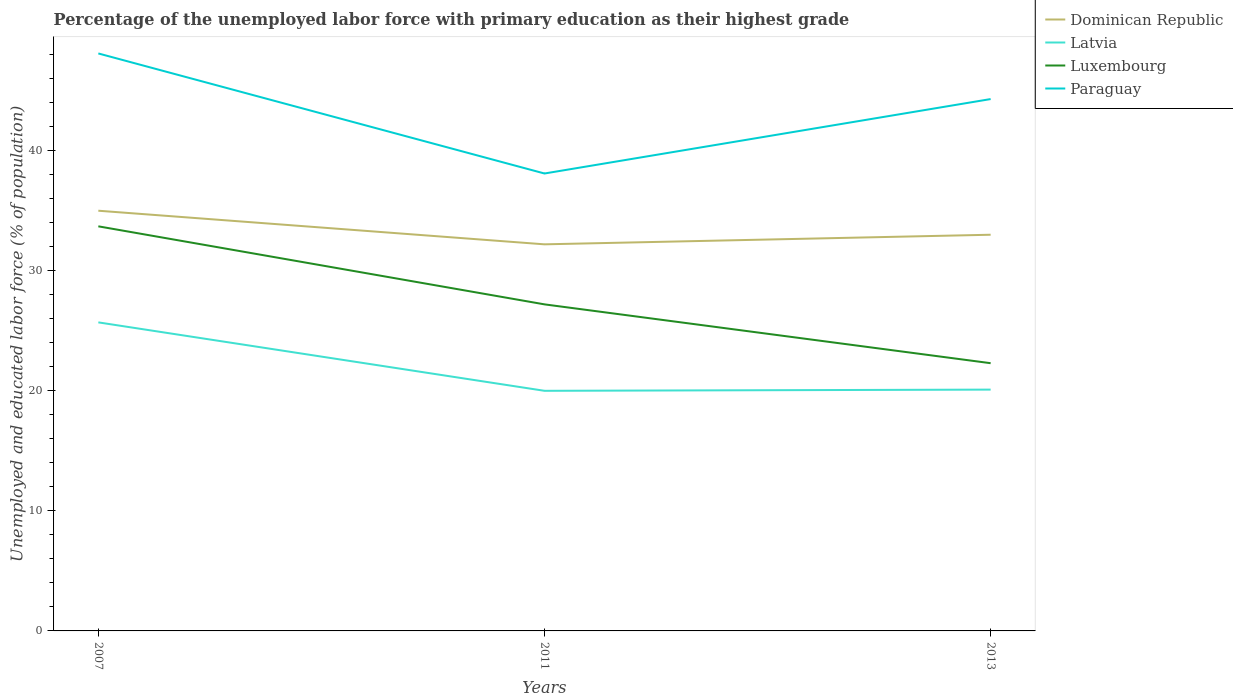How many different coloured lines are there?
Your answer should be compact. 4. Does the line corresponding to Luxembourg intersect with the line corresponding to Paraguay?
Give a very brief answer. No. Across all years, what is the maximum percentage of the unemployed labor force with primary education in Luxembourg?
Offer a terse response. 22.3. What is the difference between the highest and the second highest percentage of the unemployed labor force with primary education in Latvia?
Your answer should be very brief. 5.7. Is the percentage of the unemployed labor force with primary education in Paraguay strictly greater than the percentage of the unemployed labor force with primary education in Luxembourg over the years?
Keep it short and to the point. No. How many lines are there?
Ensure brevity in your answer.  4. How many years are there in the graph?
Your answer should be compact. 3. Are the values on the major ticks of Y-axis written in scientific E-notation?
Your answer should be compact. No. Does the graph contain any zero values?
Keep it short and to the point. No. Where does the legend appear in the graph?
Make the answer very short. Top right. How many legend labels are there?
Offer a very short reply. 4. How are the legend labels stacked?
Ensure brevity in your answer.  Vertical. What is the title of the graph?
Offer a terse response. Percentage of the unemployed labor force with primary education as their highest grade. Does "Ghana" appear as one of the legend labels in the graph?
Your answer should be compact. No. What is the label or title of the Y-axis?
Provide a succinct answer. Unemployed and educated labor force (% of population). What is the Unemployed and educated labor force (% of population) of Dominican Republic in 2007?
Offer a terse response. 35. What is the Unemployed and educated labor force (% of population) of Latvia in 2007?
Your response must be concise. 25.7. What is the Unemployed and educated labor force (% of population) in Luxembourg in 2007?
Provide a succinct answer. 33.7. What is the Unemployed and educated labor force (% of population) in Paraguay in 2007?
Keep it short and to the point. 48.1. What is the Unemployed and educated labor force (% of population) in Dominican Republic in 2011?
Offer a very short reply. 32.2. What is the Unemployed and educated labor force (% of population) of Luxembourg in 2011?
Keep it short and to the point. 27.2. What is the Unemployed and educated labor force (% of population) of Paraguay in 2011?
Your response must be concise. 38.1. What is the Unemployed and educated labor force (% of population) of Latvia in 2013?
Offer a very short reply. 20.1. What is the Unemployed and educated labor force (% of population) of Luxembourg in 2013?
Keep it short and to the point. 22.3. What is the Unemployed and educated labor force (% of population) of Paraguay in 2013?
Your response must be concise. 44.3. Across all years, what is the maximum Unemployed and educated labor force (% of population) of Dominican Republic?
Your answer should be compact. 35. Across all years, what is the maximum Unemployed and educated labor force (% of population) in Latvia?
Ensure brevity in your answer.  25.7. Across all years, what is the maximum Unemployed and educated labor force (% of population) in Luxembourg?
Offer a very short reply. 33.7. Across all years, what is the maximum Unemployed and educated labor force (% of population) of Paraguay?
Your answer should be very brief. 48.1. Across all years, what is the minimum Unemployed and educated labor force (% of population) of Dominican Republic?
Provide a short and direct response. 32.2. Across all years, what is the minimum Unemployed and educated labor force (% of population) in Luxembourg?
Make the answer very short. 22.3. Across all years, what is the minimum Unemployed and educated labor force (% of population) of Paraguay?
Give a very brief answer. 38.1. What is the total Unemployed and educated labor force (% of population) of Dominican Republic in the graph?
Make the answer very short. 100.2. What is the total Unemployed and educated labor force (% of population) of Latvia in the graph?
Your answer should be compact. 65.8. What is the total Unemployed and educated labor force (% of population) in Luxembourg in the graph?
Ensure brevity in your answer.  83.2. What is the total Unemployed and educated labor force (% of population) in Paraguay in the graph?
Provide a succinct answer. 130.5. What is the difference between the Unemployed and educated labor force (% of population) of Luxembourg in 2007 and that in 2011?
Ensure brevity in your answer.  6.5. What is the difference between the Unemployed and educated labor force (% of population) in Dominican Republic in 2011 and that in 2013?
Your response must be concise. -0.8. What is the difference between the Unemployed and educated labor force (% of population) in Latvia in 2011 and that in 2013?
Your response must be concise. -0.1. What is the difference between the Unemployed and educated labor force (% of population) of Luxembourg in 2011 and that in 2013?
Give a very brief answer. 4.9. What is the difference between the Unemployed and educated labor force (% of population) in Paraguay in 2011 and that in 2013?
Keep it short and to the point. -6.2. What is the difference between the Unemployed and educated labor force (% of population) of Dominican Republic in 2007 and the Unemployed and educated labor force (% of population) of Latvia in 2011?
Your answer should be very brief. 15. What is the difference between the Unemployed and educated labor force (% of population) of Dominican Republic in 2007 and the Unemployed and educated labor force (% of population) of Luxembourg in 2011?
Offer a very short reply. 7.8. What is the difference between the Unemployed and educated labor force (% of population) of Dominican Republic in 2007 and the Unemployed and educated labor force (% of population) of Paraguay in 2011?
Offer a terse response. -3.1. What is the difference between the Unemployed and educated labor force (% of population) of Luxembourg in 2007 and the Unemployed and educated labor force (% of population) of Paraguay in 2011?
Your answer should be compact. -4.4. What is the difference between the Unemployed and educated labor force (% of population) in Dominican Republic in 2007 and the Unemployed and educated labor force (% of population) in Luxembourg in 2013?
Ensure brevity in your answer.  12.7. What is the difference between the Unemployed and educated labor force (% of population) of Dominican Republic in 2007 and the Unemployed and educated labor force (% of population) of Paraguay in 2013?
Your response must be concise. -9.3. What is the difference between the Unemployed and educated labor force (% of population) in Latvia in 2007 and the Unemployed and educated labor force (% of population) in Paraguay in 2013?
Provide a succinct answer. -18.6. What is the difference between the Unemployed and educated labor force (% of population) in Luxembourg in 2007 and the Unemployed and educated labor force (% of population) in Paraguay in 2013?
Keep it short and to the point. -10.6. What is the difference between the Unemployed and educated labor force (% of population) in Dominican Republic in 2011 and the Unemployed and educated labor force (% of population) in Latvia in 2013?
Make the answer very short. 12.1. What is the difference between the Unemployed and educated labor force (% of population) in Dominican Republic in 2011 and the Unemployed and educated labor force (% of population) in Paraguay in 2013?
Ensure brevity in your answer.  -12.1. What is the difference between the Unemployed and educated labor force (% of population) of Latvia in 2011 and the Unemployed and educated labor force (% of population) of Paraguay in 2013?
Ensure brevity in your answer.  -24.3. What is the difference between the Unemployed and educated labor force (% of population) in Luxembourg in 2011 and the Unemployed and educated labor force (% of population) in Paraguay in 2013?
Ensure brevity in your answer.  -17.1. What is the average Unemployed and educated labor force (% of population) in Dominican Republic per year?
Make the answer very short. 33.4. What is the average Unemployed and educated labor force (% of population) of Latvia per year?
Your answer should be compact. 21.93. What is the average Unemployed and educated labor force (% of population) of Luxembourg per year?
Offer a terse response. 27.73. What is the average Unemployed and educated labor force (% of population) in Paraguay per year?
Your answer should be compact. 43.5. In the year 2007, what is the difference between the Unemployed and educated labor force (% of population) of Dominican Republic and Unemployed and educated labor force (% of population) of Luxembourg?
Ensure brevity in your answer.  1.3. In the year 2007, what is the difference between the Unemployed and educated labor force (% of population) in Dominican Republic and Unemployed and educated labor force (% of population) in Paraguay?
Make the answer very short. -13.1. In the year 2007, what is the difference between the Unemployed and educated labor force (% of population) in Latvia and Unemployed and educated labor force (% of population) in Luxembourg?
Offer a very short reply. -8. In the year 2007, what is the difference between the Unemployed and educated labor force (% of population) of Latvia and Unemployed and educated labor force (% of population) of Paraguay?
Provide a succinct answer. -22.4. In the year 2007, what is the difference between the Unemployed and educated labor force (% of population) in Luxembourg and Unemployed and educated labor force (% of population) in Paraguay?
Offer a very short reply. -14.4. In the year 2011, what is the difference between the Unemployed and educated labor force (% of population) in Dominican Republic and Unemployed and educated labor force (% of population) in Latvia?
Provide a short and direct response. 12.2. In the year 2011, what is the difference between the Unemployed and educated labor force (% of population) of Dominican Republic and Unemployed and educated labor force (% of population) of Luxembourg?
Your response must be concise. 5. In the year 2011, what is the difference between the Unemployed and educated labor force (% of population) in Dominican Republic and Unemployed and educated labor force (% of population) in Paraguay?
Provide a short and direct response. -5.9. In the year 2011, what is the difference between the Unemployed and educated labor force (% of population) in Latvia and Unemployed and educated labor force (% of population) in Luxembourg?
Provide a short and direct response. -7.2. In the year 2011, what is the difference between the Unemployed and educated labor force (% of population) of Latvia and Unemployed and educated labor force (% of population) of Paraguay?
Ensure brevity in your answer.  -18.1. In the year 2011, what is the difference between the Unemployed and educated labor force (% of population) of Luxembourg and Unemployed and educated labor force (% of population) of Paraguay?
Ensure brevity in your answer.  -10.9. In the year 2013, what is the difference between the Unemployed and educated labor force (% of population) of Dominican Republic and Unemployed and educated labor force (% of population) of Latvia?
Offer a very short reply. 12.9. In the year 2013, what is the difference between the Unemployed and educated labor force (% of population) in Dominican Republic and Unemployed and educated labor force (% of population) in Luxembourg?
Offer a terse response. 10.7. In the year 2013, what is the difference between the Unemployed and educated labor force (% of population) in Latvia and Unemployed and educated labor force (% of population) in Luxembourg?
Keep it short and to the point. -2.2. In the year 2013, what is the difference between the Unemployed and educated labor force (% of population) of Latvia and Unemployed and educated labor force (% of population) of Paraguay?
Provide a succinct answer. -24.2. In the year 2013, what is the difference between the Unemployed and educated labor force (% of population) in Luxembourg and Unemployed and educated labor force (% of population) in Paraguay?
Give a very brief answer. -22. What is the ratio of the Unemployed and educated labor force (% of population) in Dominican Republic in 2007 to that in 2011?
Your answer should be compact. 1.09. What is the ratio of the Unemployed and educated labor force (% of population) of Latvia in 2007 to that in 2011?
Provide a succinct answer. 1.28. What is the ratio of the Unemployed and educated labor force (% of population) in Luxembourg in 2007 to that in 2011?
Your answer should be compact. 1.24. What is the ratio of the Unemployed and educated labor force (% of population) of Paraguay in 2007 to that in 2011?
Offer a terse response. 1.26. What is the ratio of the Unemployed and educated labor force (% of population) of Dominican Republic in 2007 to that in 2013?
Give a very brief answer. 1.06. What is the ratio of the Unemployed and educated labor force (% of population) in Latvia in 2007 to that in 2013?
Ensure brevity in your answer.  1.28. What is the ratio of the Unemployed and educated labor force (% of population) of Luxembourg in 2007 to that in 2013?
Provide a succinct answer. 1.51. What is the ratio of the Unemployed and educated labor force (% of population) in Paraguay in 2007 to that in 2013?
Your answer should be very brief. 1.09. What is the ratio of the Unemployed and educated labor force (% of population) in Dominican Republic in 2011 to that in 2013?
Offer a terse response. 0.98. What is the ratio of the Unemployed and educated labor force (% of population) of Latvia in 2011 to that in 2013?
Offer a very short reply. 0.99. What is the ratio of the Unemployed and educated labor force (% of population) of Luxembourg in 2011 to that in 2013?
Ensure brevity in your answer.  1.22. What is the ratio of the Unemployed and educated labor force (% of population) in Paraguay in 2011 to that in 2013?
Keep it short and to the point. 0.86. What is the difference between the highest and the second highest Unemployed and educated labor force (% of population) in Latvia?
Provide a succinct answer. 5.6. What is the difference between the highest and the lowest Unemployed and educated labor force (% of population) in Luxembourg?
Ensure brevity in your answer.  11.4. 